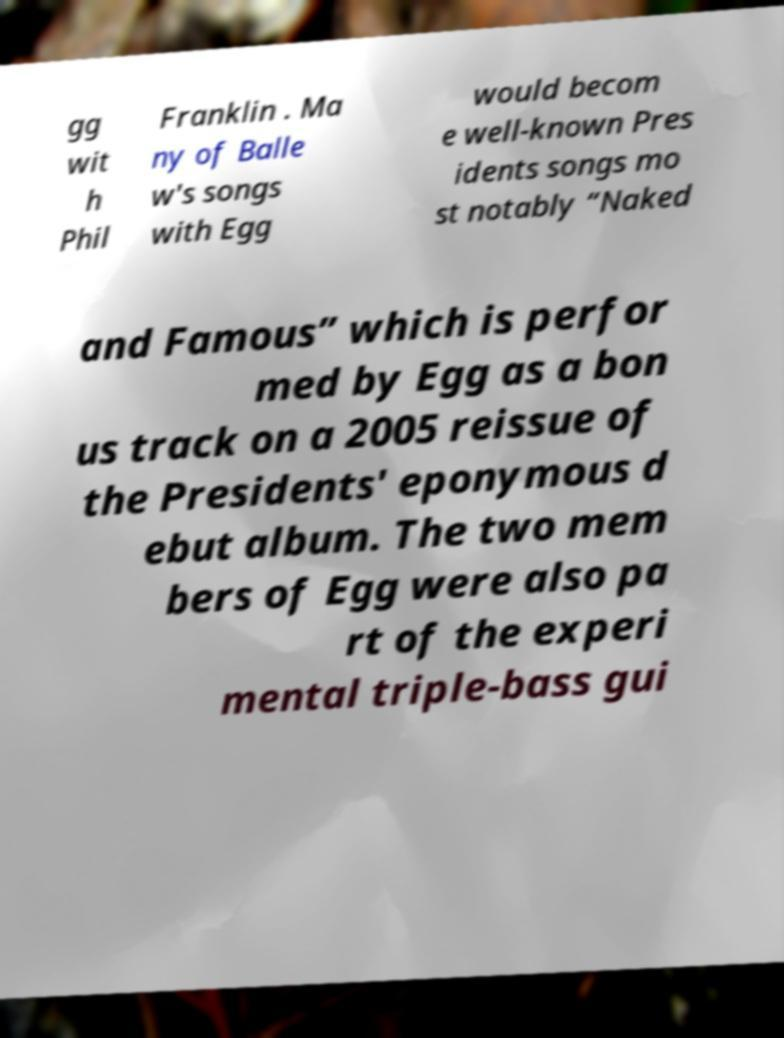Could you extract and type out the text from this image? gg wit h Phil Franklin . Ma ny of Balle w's songs with Egg would becom e well-known Pres idents songs mo st notably “Naked and Famous” which is perfor med by Egg as a bon us track on a 2005 reissue of the Presidents' eponymous d ebut album. The two mem bers of Egg were also pa rt of the experi mental triple-bass gui 